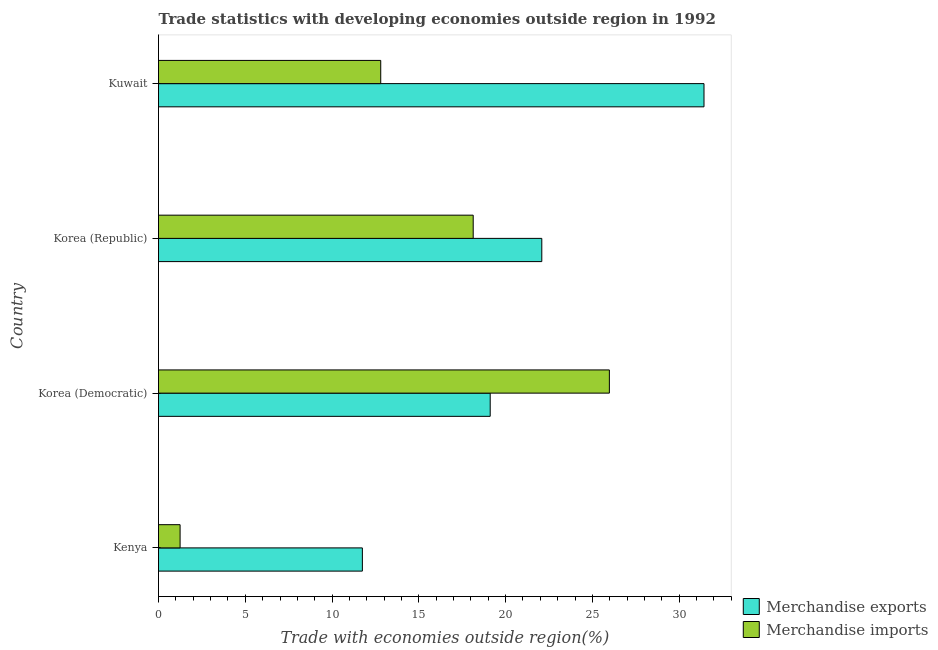How many different coloured bars are there?
Your answer should be compact. 2. How many groups of bars are there?
Give a very brief answer. 4. Are the number of bars on each tick of the Y-axis equal?
Offer a very short reply. Yes. What is the label of the 1st group of bars from the top?
Provide a short and direct response. Kuwait. What is the merchandise imports in Kuwait?
Provide a succinct answer. 12.8. Across all countries, what is the maximum merchandise exports?
Offer a very short reply. 31.43. Across all countries, what is the minimum merchandise exports?
Make the answer very short. 11.75. In which country was the merchandise exports maximum?
Give a very brief answer. Kuwait. In which country was the merchandise exports minimum?
Make the answer very short. Kenya. What is the total merchandise imports in the graph?
Offer a terse response. 58.16. What is the difference between the merchandise exports in Korea (Republic) and that in Kuwait?
Offer a terse response. -9.35. What is the difference between the merchandise imports in Kuwait and the merchandise exports in Korea (Republic)?
Give a very brief answer. -9.28. What is the average merchandise exports per country?
Offer a very short reply. 21.09. What is the difference between the merchandise imports and merchandise exports in Kuwait?
Provide a succinct answer. -18.63. What is the ratio of the merchandise imports in Kenya to that in Korea (Republic)?
Your response must be concise. 0.07. Is the merchandise exports in Korea (Democratic) less than that in Kuwait?
Provide a succinct answer. Yes. What is the difference between the highest and the second highest merchandise exports?
Your answer should be very brief. 9.35. What is the difference between the highest and the lowest merchandise imports?
Make the answer very short. 24.73. In how many countries, is the merchandise exports greater than the average merchandise exports taken over all countries?
Your answer should be compact. 2. Is the sum of the merchandise exports in Kenya and Kuwait greater than the maximum merchandise imports across all countries?
Give a very brief answer. Yes. What does the 1st bar from the top in Kuwait represents?
Give a very brief answer. Merchandise imports. What does the 2nd bar from the bottom in Kuwait represents?
Keep it short and to the point. Merchandise imports. Does the graph contain grids?
Provide a succinct answer. No. Where does the legend appear in the graph?
Offer a terse response. Bottom right. How are the legend labels stacked?
Give a very brief answer. Vertical. What is the title of the graph?
Keep it short and to the point. Trade statistics with developing economies outside region in 1992. What is the label or title of the X-axis?
Give a very brief answer. Trade with economies outside region(%). What is the Trade with economies outside region(%) in Merchandise exports in Kenya?
Offer a terse response. 11.75. What is the Trade with economies outside region(%) of Merchandise imports in Kenya?
Give a very brief answer. 1.24. What is the Trade with economies outside region(%) of Merchandise exports in Korea (Democratic)?
Provide a succinct answer. 19.11. What is the Trade with economies outside region(%) in Merchandise imports in Korea (Democratic)?
Make the answer very short. 25.98. What is the Trade with economies outside region(%) of Merchandise exports in Korea (Republic)?
Your answer should be compact. 22.08. What is the Trade with economies outside region(%) in Merchandise imports in Korea (Republic)?
Provide a short and direct response. 18.13. What is the Trade with economies outside region(%) in Merchandise exports in Kuwait?
Offer a terse response. 31.43. What is the Trade with economies outside region(%) in Merchandise imports in Kuwait?
Your answer should be very brief. 12.8. Across all countries, what is the maximum Trade with economies outside region(%) in Merchandise exports?
Offer a terse response. 31.43. Across all countries, what is the maximum Trade with economies outside region(%) of Merchandise imports?
Provide a succinct answer. 25.98. Across all countries, what is the minimum Trade with economies outside region(%) in Merchandise exports?
Offer a very short reply. 11.75. Across all countries, what is the minimum Trade with economies outside region(%) in Merchandise imports?
Provide a short and direct response. 1.24. What is the total Trade with economies outside region(%) in Merchandise exports in the graph?
Provide a short and direct response. 84.37. What is the total Trade with economies outside region(%) of Merchandise imports in the graph?
Your response must be concise. 58.16. What is the difference between the Trade with economies outside region(%) of Merchandise exports in Kenya and that in Korea (Democratic)?
Provide a succinct answer. -7.37. What is the difference between the Trade with economies outside region(%) in Merchandise imports in Kenya and that in Korea (Democratic)?
Provide a short and direct response. -24.73. What is the difference between the Trade with economies outside region(%) in Merchandise exports in Kenya and that in Korea (Republic)?
Ensure brevity in your answer.  -10.34. What is the difference between the Trade with economies outside region(%) in Merchandise imports in Kenya and that in Korea (Republic)?
Give a very brief answer. -16.89. What is the difference between the Trade with economies outside region(%) in Merchandise exports in Kenya and that in Kuwait?
Offer a terse response. -19.68. What is the difference between the Trade with economies outside region(%) of Merchandise imports in Kenya and that in Kuwait?
Make the answer very short. -11.56. What is the difference between the Trade with economies outside region(%) of Merchandise exports in Korea (Democratic) and that in Korea (Republic)?
Make the answer very short. -2.97. What is the difference between the Trade with economies outside region(%) of Merchandise imports in Korea (Democratic) and that in Korea (Republic)?
Keep it short and to the point. 7.85. What is the difference between the Trade with economies outside region(%) of Merchandise exports in Korea (Democratic) and that in Kuwait?
Keep it short and to the point. -12.32. What is the difference between the Trade with economies outside region(%) in Merchandise imports in Korea (Democratic) and that in Kuwait?
Give a very brief answer. 13.17. What is the difference between the Trade with economies outside region(%) in Merchandise exports in Korea (Republic) and that in Kuwait?
Offer a terse response. -9.35. What is the difference between the Trade with economies outside region(%) of Merchandise imports in Korea (Republic) and that in Kuwait?
Offer a terse response. 5.33. What is the difference between the Trade with economies outside region(%) in Merchandise exports in Kenya and the Trade with economies outside region(%) in Merchandise imports in Korea (Democratic)?
Offer a terse response. -14.23. What is the difference between the Trade with economies outside region(%) in Merchandise exports in Kenya and the Trade with economies outside region(%) in Merchandise imports in Korea (Republic)?
Make the answer very short. -6.39. What is the difference between the Trade with economies outside region(%) of Merchandise exports in Kenya and the Trade with economies outside region(%) of Merchandise imports in Kuwait?
Ensure brevity in your answer.  -1.06. What is the difference between the Trade with economies outside region(%) of Merchandise exports in Korea (Democratic) and the Trade with economies outside region(%) of Merchandise imports in Korea (Republic)?
Your answer should be very brief. 0.98. What is the difference between the Trade with economies outside region(%) of Merchandise exports in Korea (Democratic) and the Trade with economies outside region(%) of Merchandise imports in Kuwait?
Keep it short and to the point. 6.31. What is the difference between the Trade with economies outside region(%) in Merchandise exports in Korea (Republic) and the Trade with economies outside region(%) in Merchandise imports in Kuwait?
Ensure brevity in your answer.  9.28. What is the average Trade with economies outside region(%) in Merchandise exports per country?
Keep it short and to the point. 21.09. What is the average Trade with economies outside region(%) of Merchandise imports per country?
Your response must be concise. 14.54. What is the difference between the Trade with economies outside region(%) in Merchandise exports and Trade with economies outside region(%) in Merchandise imports in Kenya?
Your answer should be compact. 10.5. What is the difference between the Trade with economies outside region(%) in Merchandise exports and Trade with economies outside region(%) in Merchandise imports in Korea (Democratic)?
Offer a terse response. -6.87. What is the difference between the Trade with economies outside region(%) in Merchandise exports and Trade with economies outside region(%) in Merchandise imports in Korea (Republic)?
Your response must be concise. 3.95. What is the difference between the Trade with economies outside region(%) of Merchandise exports and Trade with economies outside region(%) of Merchandise imports in Kuwait?
Provide a succinct answer. 18.63. What is the ratio of the Trade with economies outside region(%) of Merchandise exports in Kenya to that in Korea (Democratic)?
Give a very brief answer. 0.61. What is the ratio of the Trade with economies outside region(%) of Merchandise imports in Kenya to that in Korea (Democratic)?
Your response must be concise. 0.05. What is the ratio of the Trade with economies outside region(%) in Merchandise exports in Kenya to that in Korea (Republic)?
Your answer should be compact. 0.53. What is the ratio of the Trade with economies outside region(%) of Merchandise imports in Kenya to that in Korea (Republic)?
Provide a succinct answer. 0.07. What is the ratio of the Trade with economies outside region(%) in Merchandise exports in Kenya to that in Kuwait?
Give a very brief answer. 0.37. What is the ratio of the Trade with economies outside region(%) in Merchandise imports in Kenya to that in Kuwait?
Your answer should be compact. 0.1. What is the ratio of the Trade with economies outside region(%) in Merchandise exports in Korea (Democratic) to that in Korea (Republic)?
Provide a succinct answer. 0.87. What is the ratio of the Trade with economies outside region(%) in Merchandise imports in Korea (Democratic) to that in Korea (Republic)?
Your answer should be compact. 1.43. What is the ratio of the Trade with economies outside region(%) in Merchandise exports in Korea (Democratic) to that in Kuwait?
Make the answer very short. 0.61. What is the ratio of the Trade with economies outside region(%) in Merchandise imports in Korea (Democratic) to that in Kuwait?
Ensure brevity in your answer.  2.03. What is the ratio of the Trade with economies outside region(%) of Merchandise exports in Korea (Republic) to that in Kuwait?
Provide a succinct answer. 0.7. What is the ratio of the Trade with economies outside region(%) of Merchandise imports in Korea (Republic) to that in Kuwait?
Offer a very short reply. 1.42. What is the difference between the highest and the second highest Trade with economies outside region(%) of Merchandise exports?
Your answer should be compact. 9.35. What is the difference between the highest and the second highest Trade with economies outside region(%) of Merchandise imports?
Your response must be concise. 7.85. What is the difference between the highest and the lowest Trade with economies outside region(%) in Merchandise exports?
Provide a succinct answer. 19.68. What is the difference between the highest and the lowest Trade with economies outside region(%) of Merchandise imports?
Your response must be concise. 24.73. 